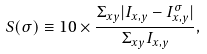Convert formula to latex. <formula><loc_0><loc_0><loc_500><loc_500>S ( \sigma ) \equiv 1 0 \times \frac { \Sigma _ { x y } | I _ { x , y } - I _ { x , y } ^ { \sigma } | } { \Sigma _ { x y } I _ { x , y } } ,</formula> 